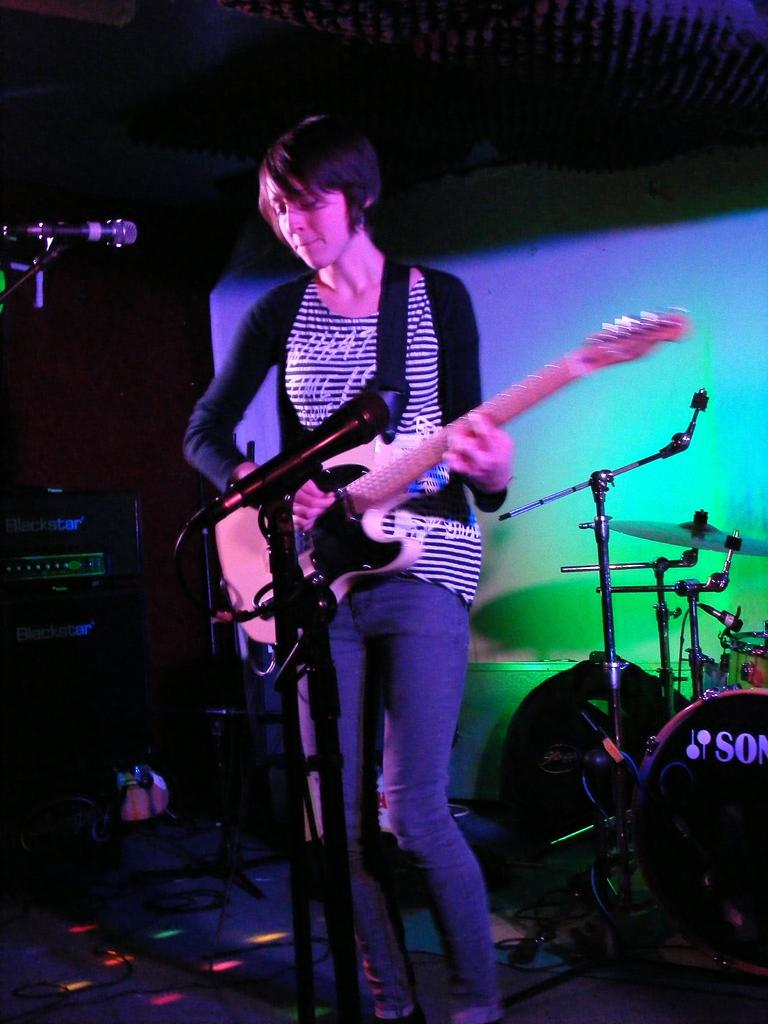What is the woman in the image doing? The woman is playing a guitar. What is the woman positioned in front of? The woman is in front of a microphone. What can be seen in the background of the image? There is a drum set and a sound system in the background of the image. What type of glove is the woman wearing while playing the guitar? The image does not show the woman wearing any gloves, so it is not possible to determine the type of glove she might be wearing. 